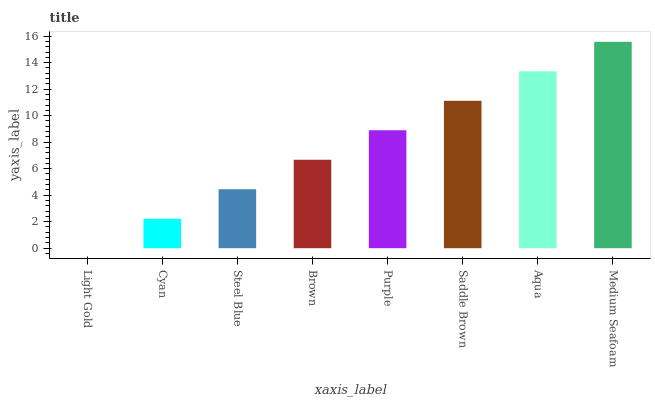Is Light Gold the minimum?
Answer yes or no. Yes. Is Medium Seafoam the maximum?
Answer yes or no. Yes. Is Cyan the minimum?
Answer yes or no. No. Is Cyan the maximum?
Answer yes or no. No. Is Cyan greater than Light Gold?
Answer yes or no. Yes. Is Light Gold less than Cyan?
Answer yes or no. Yes. Is Light Gold greater than Cyan?
Answer yes or no. No. Is Cyan less than Light Gold?
Answer yes or no. No. Is Purple the high median?
Answer yes or no. Yes. Is Brown the low median?
Answer yes or no. Yes. Is Aqua the high median?
Answer yes or no. No. Is Medium Seafoam the low median?
Answer yes or no. No. 